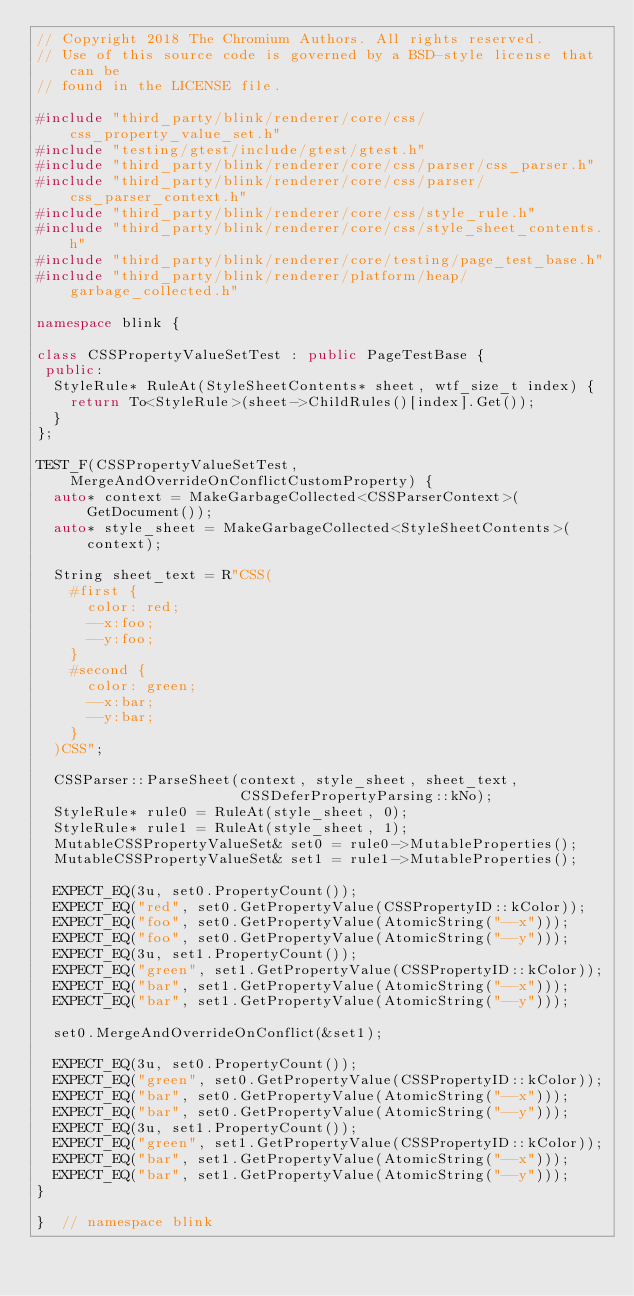Convert code to text. <code><loc_0><loc_0><loc_500><loc_500><_C++_>// Copyright 2018 The Chromium Authors. All rights reserved.
// Use of this source code is governed by a BSD-style license that can be
// found in the LICENSE file.

#include "third_party/blink/renderer/core/css/css_property_value_set.h"
#include "testing/gtest/include/gtest/gtest.h"
#include "third_party/blink/renderer/core/css/parser/css_parser.h"
#include "third_party/blink/renderer/core/css/parser/css_parser_context.h"
#include "third_party/blink/renderer/core/css/style_rule.h"
#include "third_party/blink/renderer/core/css/style_sheet_contents.h"
#include "third_party/blink/renderer/core/testing/page_test_base.h"
#include "third_party/blink/renderer/platform/heap/garbage_collected.h"

namespace blink {

class CSSPropertyValueSetTest : public PageTestBase {
 public:
  StyleRule* RuleAt(StyleSheetContents* sheet, wtf_size_t index) {
    return To<StyleRule>(sheet->ChildRules()[index].Get());
  }
};

TEST_F(CSSPropertyValueSetTest, MergeAndOverrideOnConflictCustomProperty) {
  auto* context = MakeGarbageCollected<CSSParserContext>(GetDocument());
  auto* style_sheet = MakeGarbageCollected<StyleSheetContents>(context);

  String sheet_text = R"CSS(
    #first {
      color: red;
      --x:foo;
      --y:foo;
    }
    #second {
      color: green;
      --x:bar;
      --y:bar;
    }
  )CSS";

  CSSParser::ParseSheet(context, style_sheet, sheet_text,
                        CSSDeferPropertyParsing::kNo);
  StyleRule* rule0 = RuleAt(style_sheet, 0);
  StyleRule* rule1 = RuleAt(style_sheet, 1);
  MutableCSSPropertyValueSet& set0 = rule0->MutableProperties();
  MutableCSSPropertyValueSet& set1 = rule1->MutableProperties();

  EXPECT_EQ(3u, set0.PropertyCount());
  EXPECT_EQ("red", set0.GetPropertyValue(CSSPropertyID::kColor));
  EXPECT_EQ("foo", set0.GetPropertyValue(AtomicString("--x")));
  EXPECT_EQ("foo", set0.GetPropertyValue(AtomicString("--y")));
  EXPECT_EQ(3u, set1.PropertyCount());
  EXPECT_EQ("green", set1.GetPropertyValue(CSSPropertyID::kColor));
  EXPECT_EQ("bar", set1.GetPropertyValue(AtomicString("--x")));
  EXPECT_EQ("bar", set1.GetPropertyValue(AtomicString("--y")));

  set0.MergeAndOverrideOnConflict(&set1);

  EXPECT_EQ(3u, set0.PropertyCount());
  EXPECT_EQ("green", set0.GetPropertyValue(CSSPropertyID::kColor));
  EXPECT_EQ("bar", set0.GetPropertyValue(AtomicString("--x")));
  EXPECT_EQ("bar", set0.GetPropertyValue(AtomicString("--y")));
  EXPECT_EQ(3u, set1.PropertyCount());
  EXPECT_EQ("green", set1.GetPropertyValue(CSSPropertyID::kColor));
  EXPECT_EQ("bar", set1.GetPropertyValue(AtomicString("--x")));
  EXPECT_EQ("bar", set1.GetPropertyValue(AtomicString("--y")));
}

}  // namespace blink
</code> 